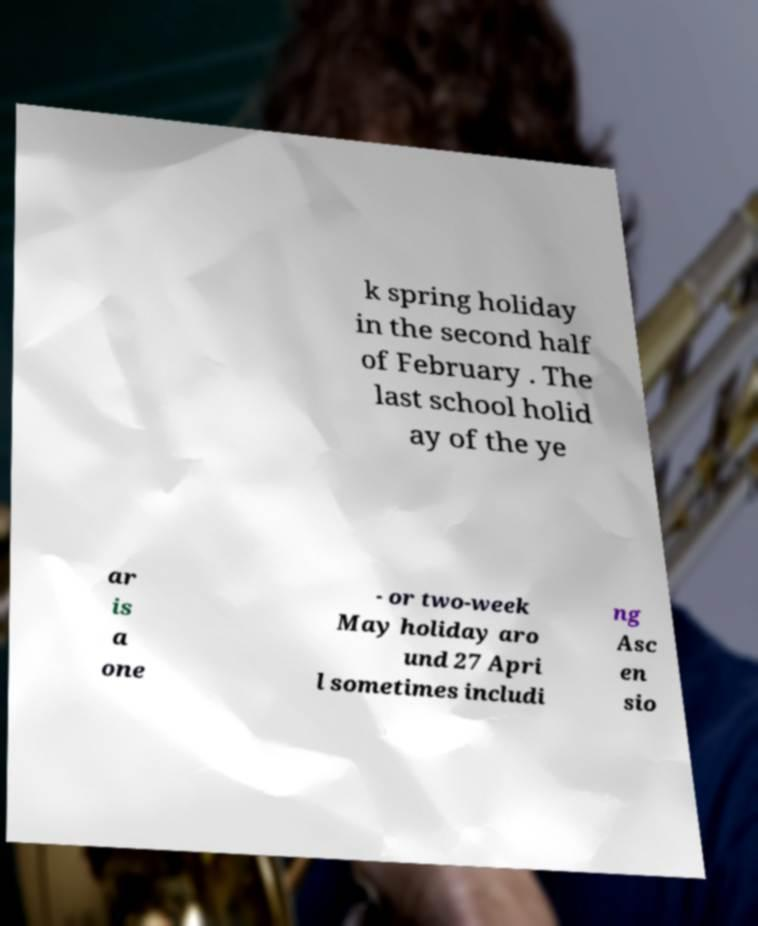Please identify and transcribe the text found in this image. k spring holiday in the second half of February . The last school holid ay of the ye ar is a one - or two-week May holiday aro und 27 Apri l sometimes includi ng Asc en sio 